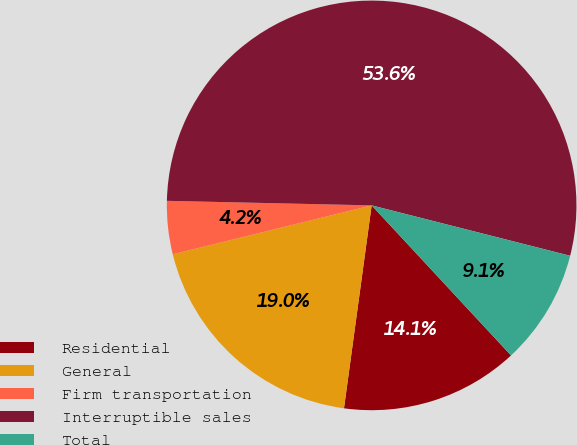<chart> <loc_0><loc_0><loc_500><loc_500><pie_chart><fcel>Residential<fcel>General<fcel>Firm transportation<fcel>Interruptible sales<fcel>Total<nl><fcel>14.07%<fcel>19.01%<fcel>4.19%<fcel>53.61%<fcel>9.13%<nl></chart> 